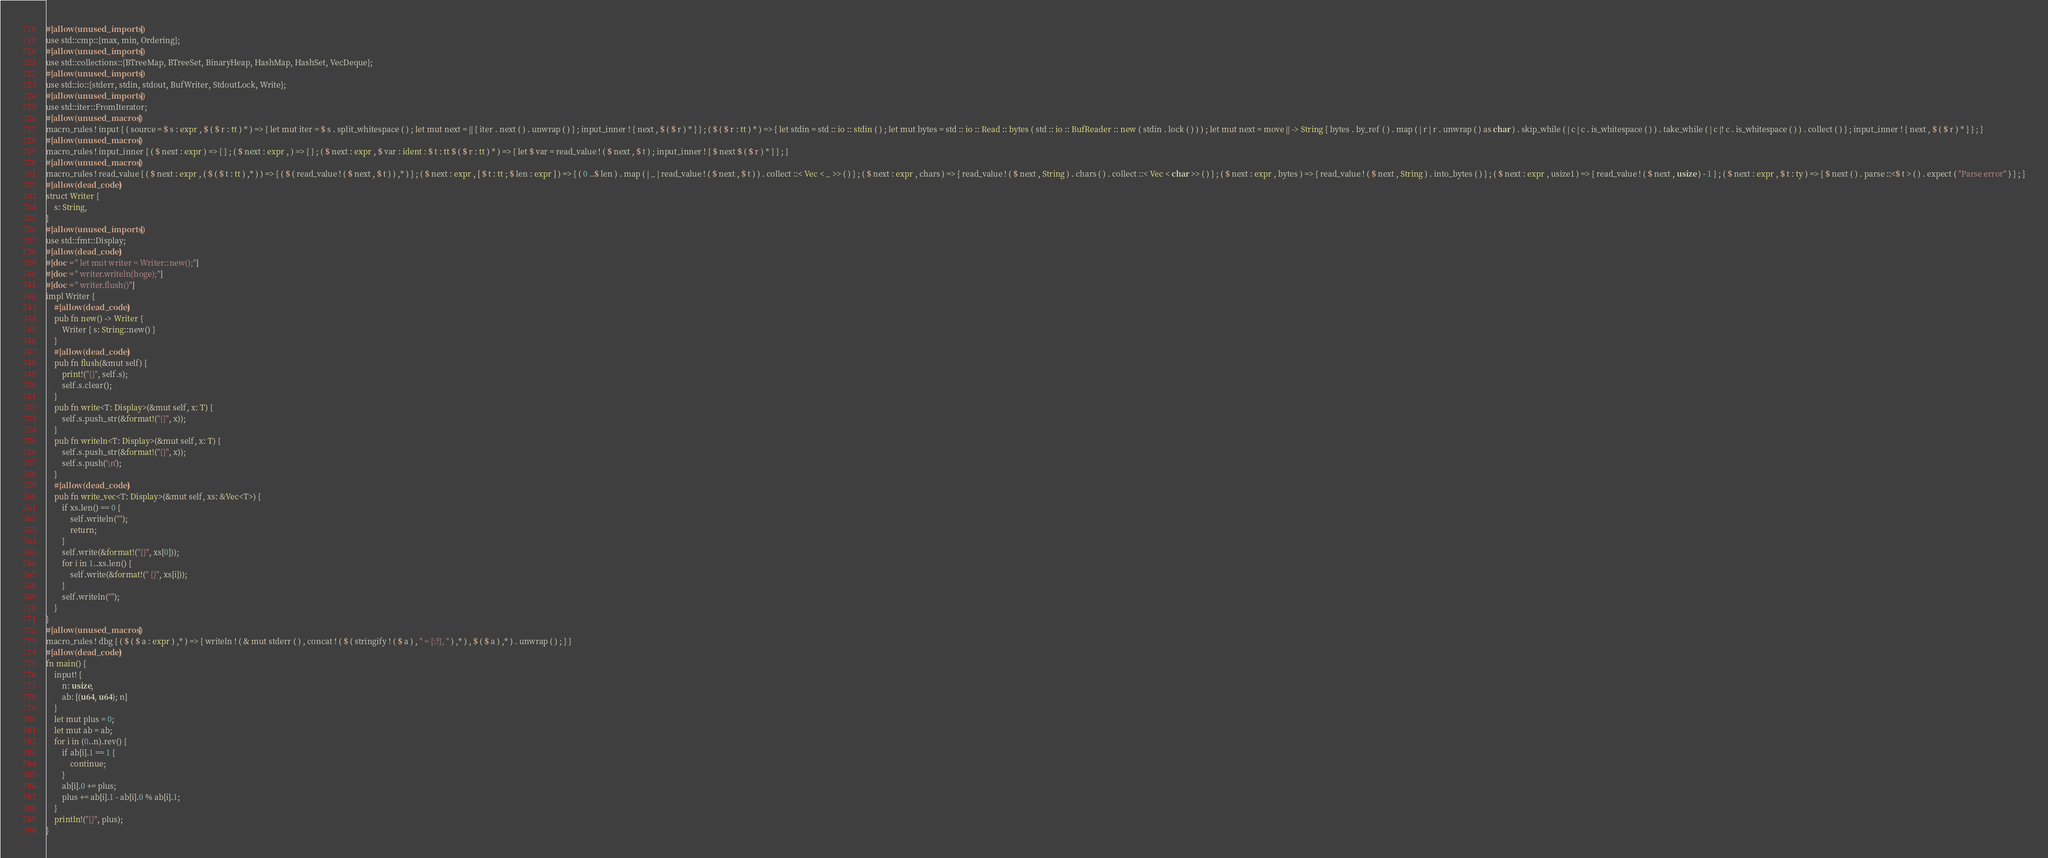Convert code to text. <code><loc_0><loc_0><loc_500><loc_500><_Rust_>#[allow(unused_imports)]
use std::cmp::{max, min, Ordering};
#[allow(unused_imports)]
use std::collections::{BTreeMap, BTreeSet, BinaryHeap, HashMap, HashSet, VecDeque};
#[allow(unused_imports)]
use std::io::{stderr, stdin, stdout, BufWriter, StdoutLock, Write};
#[allow(unused_imports)]
use std::iter::FromIterator;
#[allow(unused_macros)]
macro_rules ! input { ( source = $ s : expr , $ ( $ r : tt ) * ) => { let mut iter = $ s . split_whitespace ( ) ; let mut next = || { iter . next ( ) . unwrap ( ) } ; input_inner ! { next , $ ( $ r ) * } } ; ( $ ( $ r : tt ) * ) => { let stdin = std :: io :: stdin ( ) ; let mut bytes = std :: io :: Read :: bytes ( std :: io :: BufReader :: new ( stdin . lock ( ) ) ) ; let mut next = move || -> String { bytes . by_ref ( ) . map ( | r | r . unwrap ( ) as char ) . skip_while ( | c | c . is_whitespace ( ) ) . take_while ( | c |! c . is_whitespace ( ) ) . collect ( ) } ; input_inner ! { next , $ ( $ r ) * } } ; }
#[allow(unused_macros)]
macro_rules ! input_inner { ( $ next : expr ) => { } ; ( $ next : expr , ) => { } ; ( $ next : expr , $ var : ident : $ t : tt $ ( $ r : tt ) * ) => { let $ var = read_value ! ( $ next , $ t ) ; input_inner ! { $ next $ ( $ r ) * } } ; }
#[allow(unused_macros)]
macro_rules ! read_value { ( $ next : expr , ( $ ( $ t : tt ) ,* ) ) => { ( $ ( read_value ! ( $ next , $ t ) ) ,* ) } ; ( $ next : expr , [ $ t : tt ; $ len : expr ] ) => { ( 0 ..$ len ) . map ( | _ | read_value ! ( $ next , $ t ) ) . collect ::< Vec < _ >> ( ) } ; ( $ next : expr , chars ) => { read_value ! ( $ next , String ) . chars ( ) . collect ::< Vec < char >> ( ) } ; ( $ next : expr , bytes ) => { read_value ! ( $ next , String ) . into_bytes ( ) } ; ( $ next : expr , usize1 ) => { read_value ! ( $ next , usize ) - 1 } ; ( $ next : expr , $ t : ty ) => { $ next ( ) . parse ::<$ t > ( ) . expect ( "Parse error" ) } ; }
#[allow(dead_code)]
struct Writer {
    s: String,
}
#[allow(unused_imports)]
use std::fmt::Display;
#[allow(dead_code)]
#[doc = " let mut writer = Writer::new();"]
#[doc = " writer.writeln(hoge);"]
#[doc = " writer.flush()"]
impl Writer {
    #[allow(dead_code)]
    pub fn new() -> Writer {
        Writer { s: String::new() }
    }
    #[allow(dead_code)]
    pub fn flush(&mut self) {
        print!("{}", self.s);
        self.s.clear();
    }
    pub fn write<T: Display>(&mut self, x: T) {
        self.s.push_str(&format!("{}", x));
    }
    pub fn writeln<T: Display>(&mut self, x: T) {
        self.s.push_str(&format!("{}", x));
        self.s.push('\n');
    }
    #[allow(dead_code)]
    pub fn write_vec<T: Display>(&mut self, xs: &Vec<T>) {
        if xs.len() == 0 {
            self.writeln("");
            return;
        }
        self.write(&format!("{}", xs[0]));
        for i in 1..xs.len() {
            self.write(&format!(" {}", xs[i]));
        }
        self.writeln("");
    }
}
#[allow(unused_macros)]
macro_rules ! dbg { ( $ ( $ a : expr ) ,* ) => { writeln ! ( & mut stderr ( ) , concat ! ( $ ( stringify ! ( $ a ) , " = {:?}, " ) ,* ) , $ ( $ a ) ,* ) . unwrap ( ) ; } }
#[allow(dead_code)]
fn main() {
    input! {
        n: usize,
        ab: [(u64, u64); n]
    }
    let mut plus = 0;
    let mut ab = ab;
    for i in (0..n).rev() {
        if ab[i].1 == 1 {
            continue;
        }
        ab[i].0 += plus;
        plus += ab[i].1 - ab[i].0 % ab[i].1;
    }
    println!("{}", plus);
}</code> 